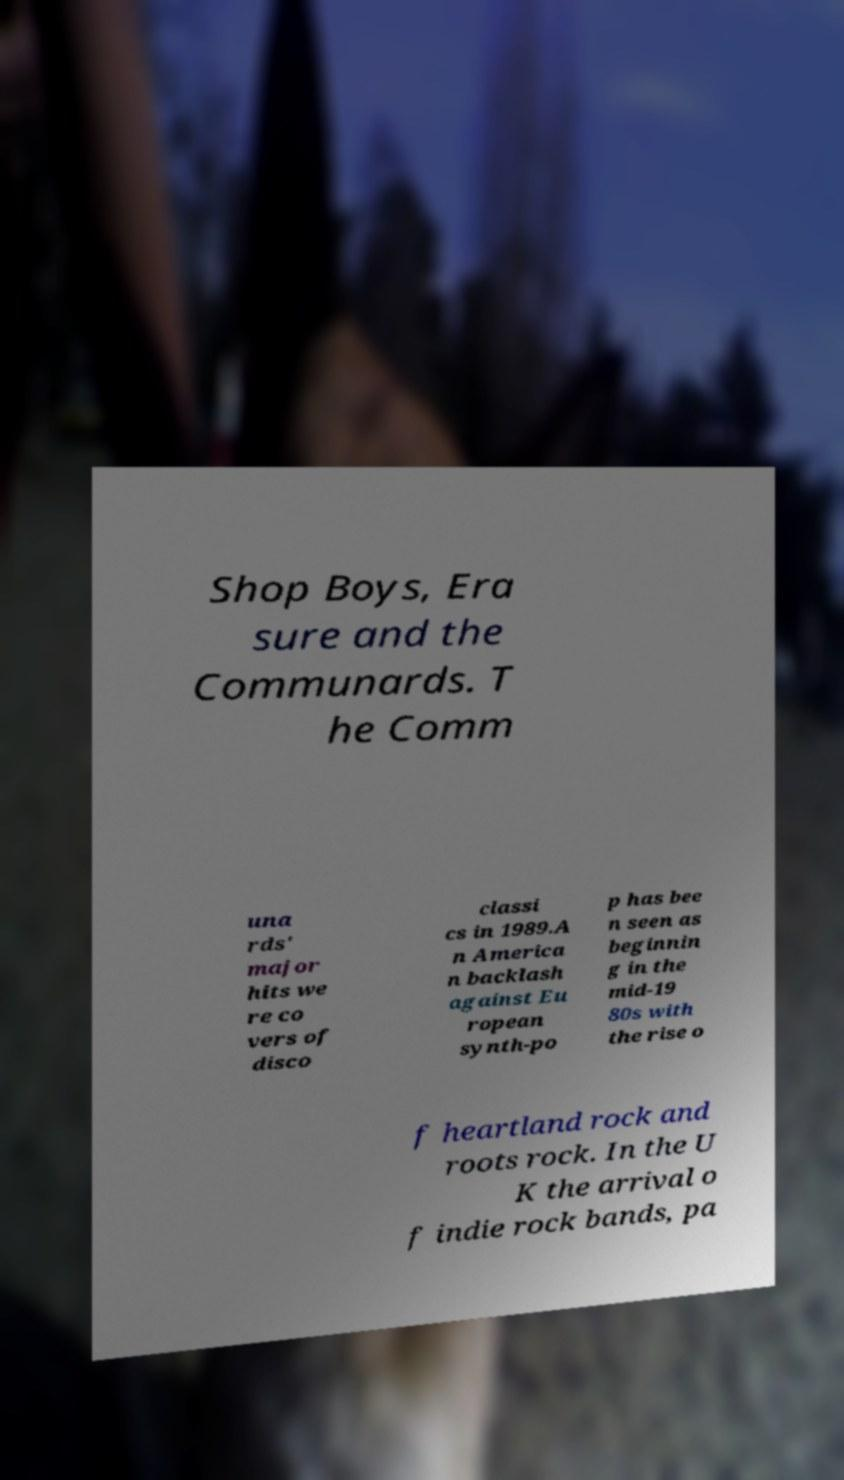Please read and relay the text visible in this image. What does it say? Shop Boys, Era sure and the Communards. T he Comm una rds' major hits we re co vers of disco classi cs in 1989.A n America n backlash against Eu ropean synth-po p has bee n seen as beginnin g in the mid-19 80s with the rise o f heartland rock and roots rock. In the U K the arrival o f indie rock bands, pa 